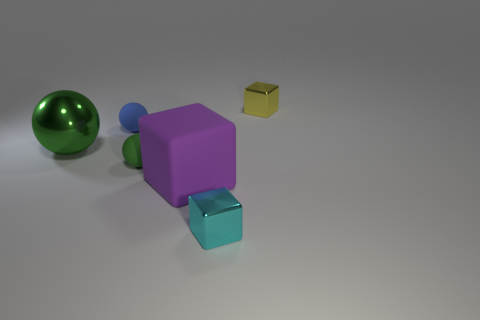Subtract all gray cubes. Subtract all blue spheres. How many cubes are left? 3 Add 2 large yellow rubber cubes. How many objects exist? 8 Add 2 big yellow matte objects. How many big yellow matte objects exist? 2 Subtract 0 brown spheres. How many objects are left? 6 Subtract all matte objects. Subtract all gray cubes. How many objects are left? 3 Add 1 blocks. How many blocks are left? 4 